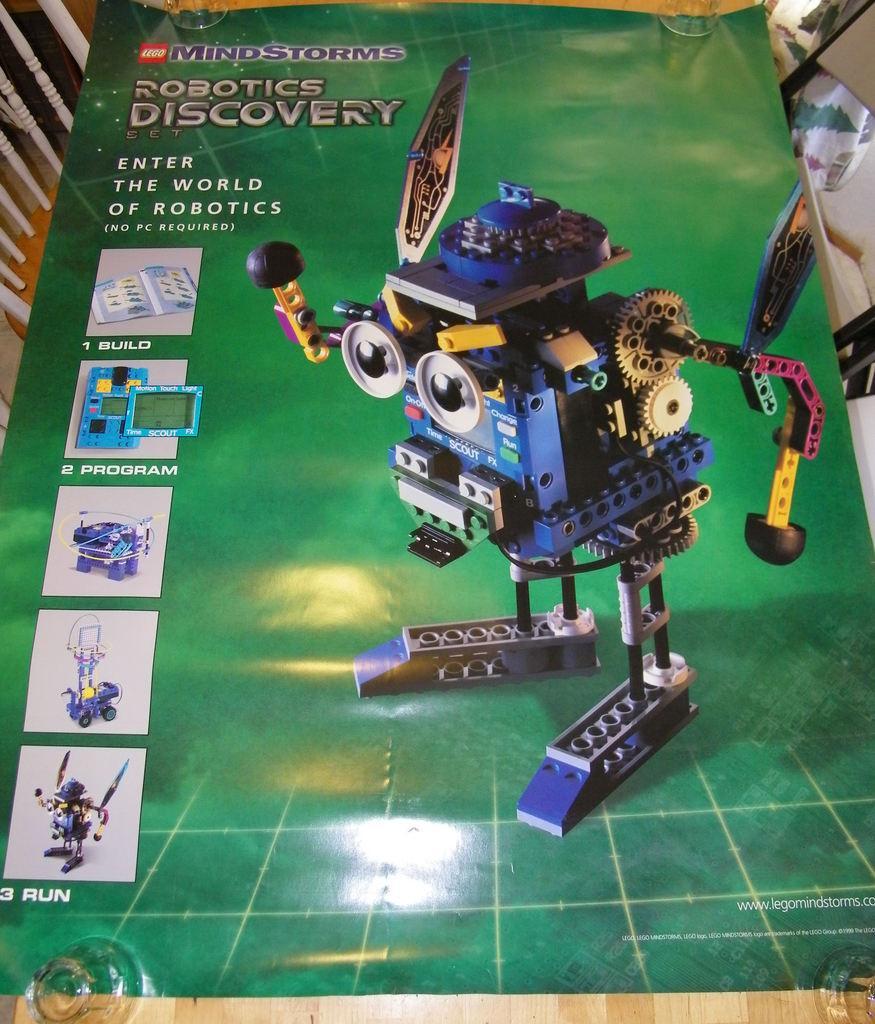How would you summarize this image in a sentence or two? In this image I can see a green colour poster and on it I can see few pictures. On the top left side of the poster I can see something is written. On the top side and on the bottom side of the image I can see four glasses. 